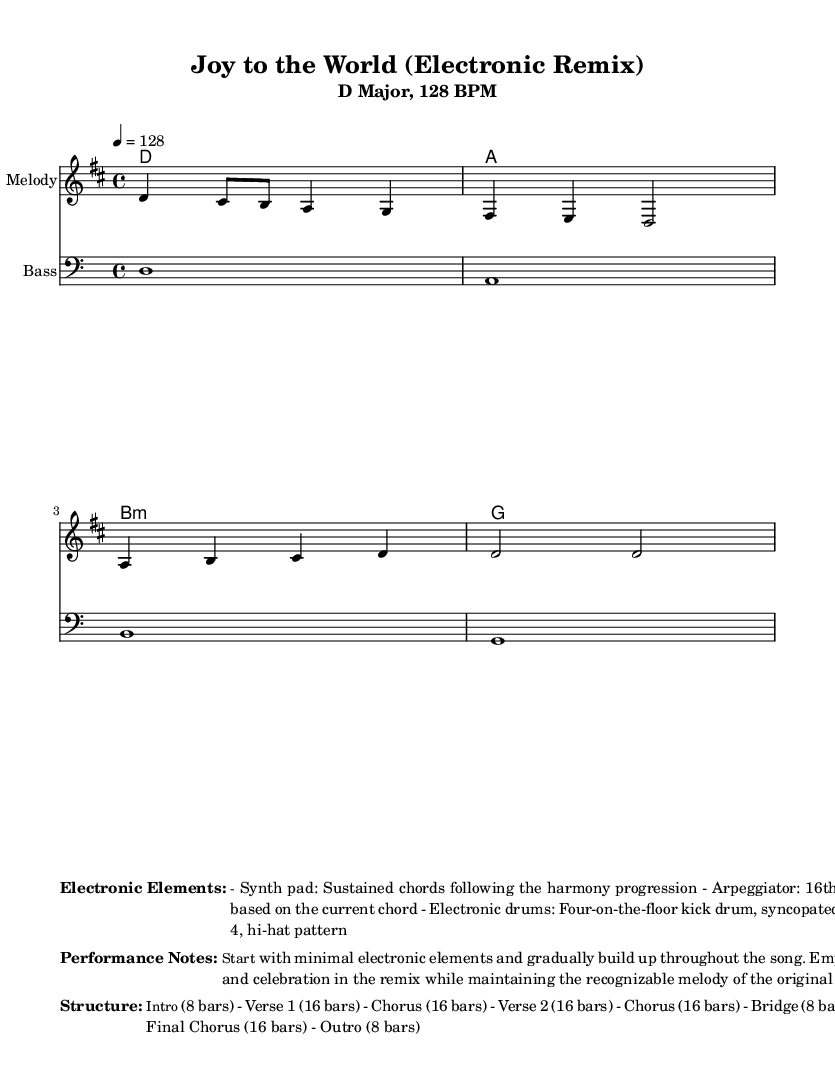What is the key signature of this music? The key signature is D major, which has two sharps (F# and C#).
Answer: D major What is the time signature? The time signature is 4/4, meaning there are four beats in each measure and the quarter note gets one beat.
Answer: 4/4 What is the tempo marking? The tempo marking indicates that the piece should be played at a pace of 128 beats per minute.
Answer: 128 BPM How many bars are in the intro section? The intro consists of 8 bars as stated in the structure outlined in the sheet music.
Answer: 8 bars Which electronic element is used for sustained chords? The music features a synth pad, designed to provide sustained chords throughout the piece.
Answer: Synth pad What is the structure of the remix? The structure includes sections such as Intro, Verse, Chorus, Bridge, and Outro, arranged in a specific order totaling to 8 sections.
Answer: Intro, Verse, Chorus, Verse, Chorus, Bridge, Final Chorus, Outro What type of drum pattern is highlighted in this remix? The drum pattern is a four-on-the-floor kick drum rhythm, accompanied by a syncopated snare on beats 2 and 4.
Answer: Four-on-the-floor 